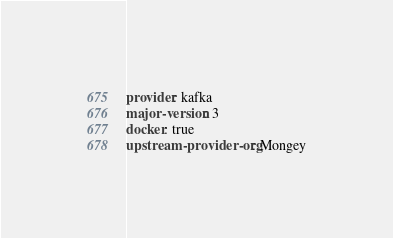<code> <loc_0><loc_0><loc_500><loc_500><_YAML_>provider: kafka
major-version: 3
docker: true
upstream-provider-org: Mongey
</code> 